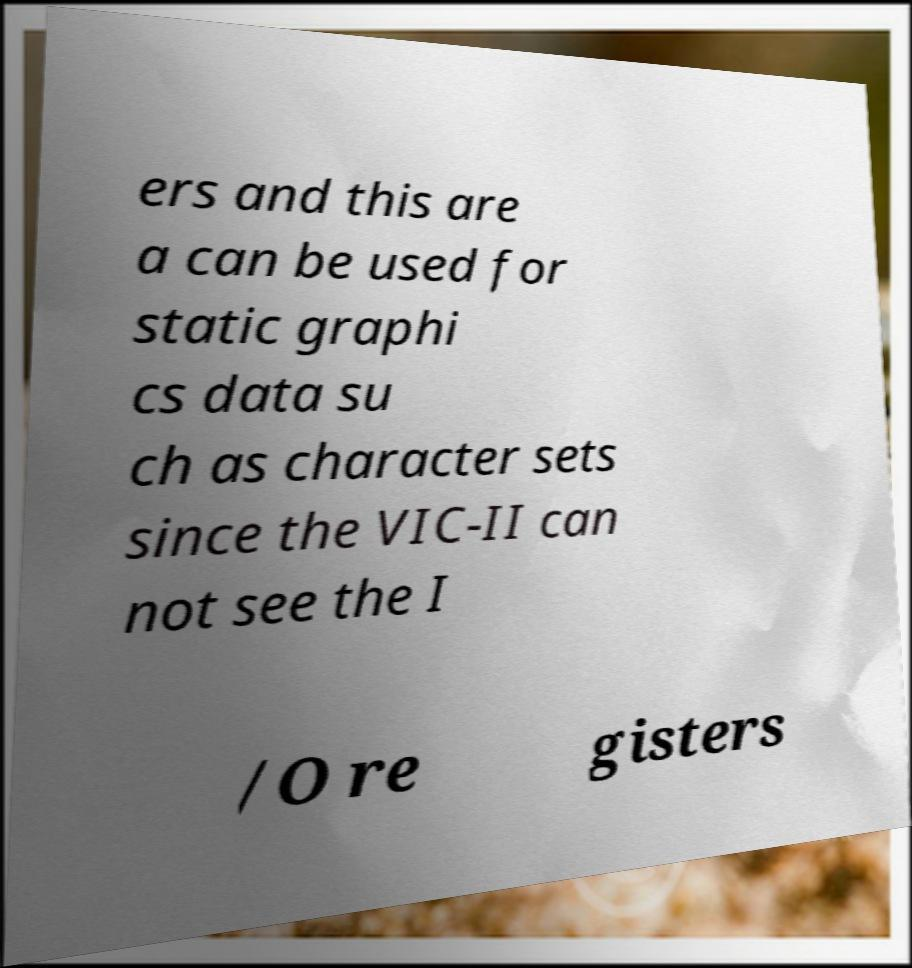Can you read and provide the text displayed in the image?This photo seems to have some interesting text. Can you extract and type it out for me? ers and this are a can be used for static graphi cs data su ch as character sets since the VIC-II can not see the I /O re gisters 